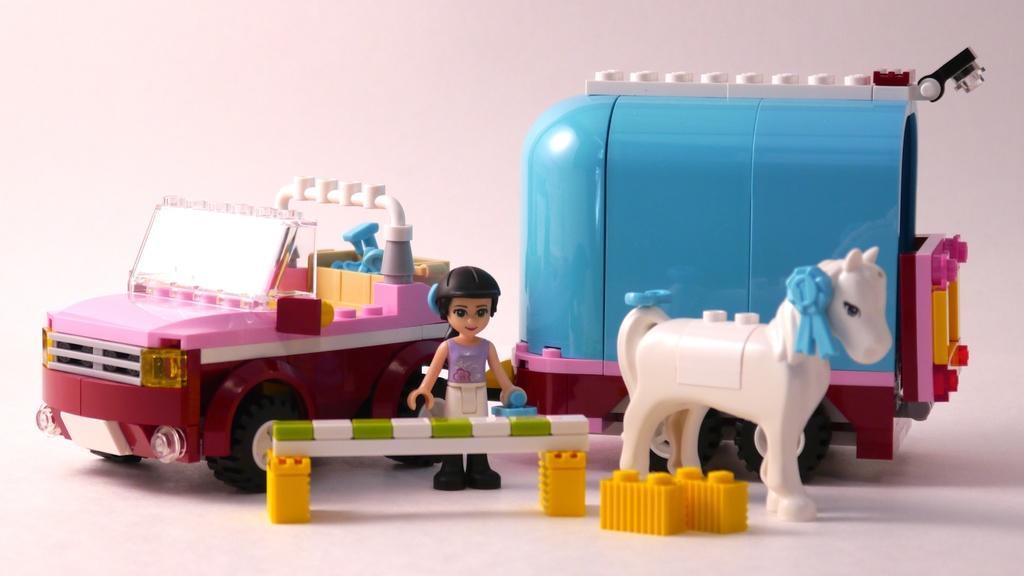What objects can be seen in the image? There are toys in the image. What surface is visible in the image? There is a floor visible in the image. How many beans are on the floor in the image? There is no mention of beans in the image; it only contains toys and a floor. 